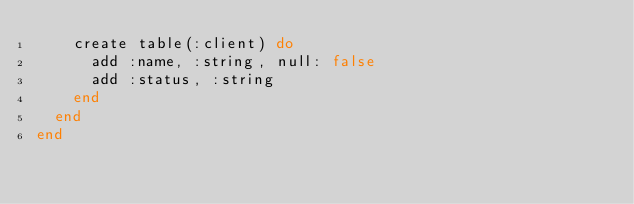Convert code to text. <code><loc_0><loc_0><loc_500><loc_500><_Elixir_>    create table(:client) do
      add :name, :string, null: false
      add :status, :string
    end
  end
end
</code> 